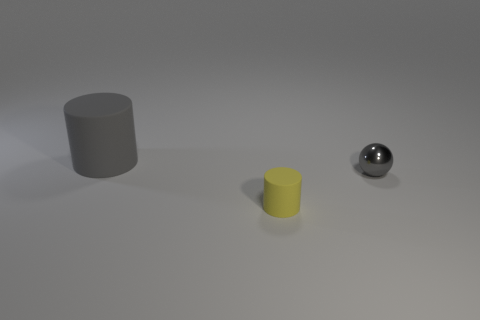Can you describe the overall composition and arrangement of objects in this image? The image presents a minimalist composition consisting of three distinct objects arranged on a flat surface. From left to right, there's a matte gray cylinder, a matte yellow, smaller cylinder, and a shiny gray ball, all of which are placed at varying distances from each other, providing a sense of depth and space. 